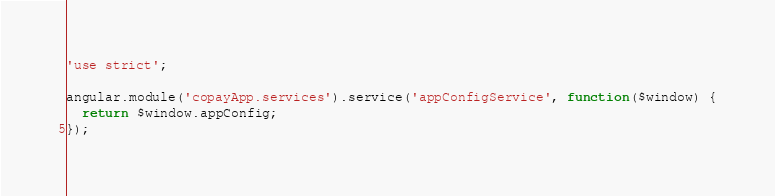Convert code to text. <code><loc_0><loc_0><loc_500><loc_500><_JavaScript_>'use strict';

angular.module('copayApp.services').service('appConfigService', function($window) {
  return $window.appConfig;
});
</code> 